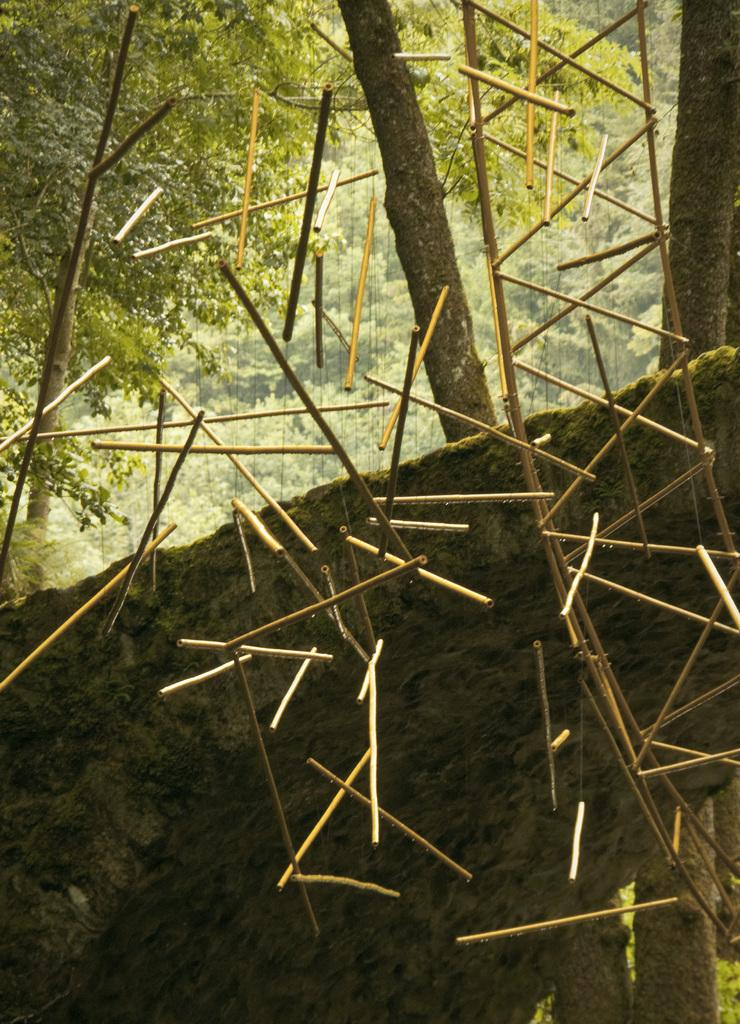What is hanging in the image? There are sticks hanging in the image. What can be seen in the background of the image? There is a rock and many trees in the background of the image. What type of plants are in harmony with the frame in the image? There is no frame present in the image, and no plants are mentioned in the provided facts. 